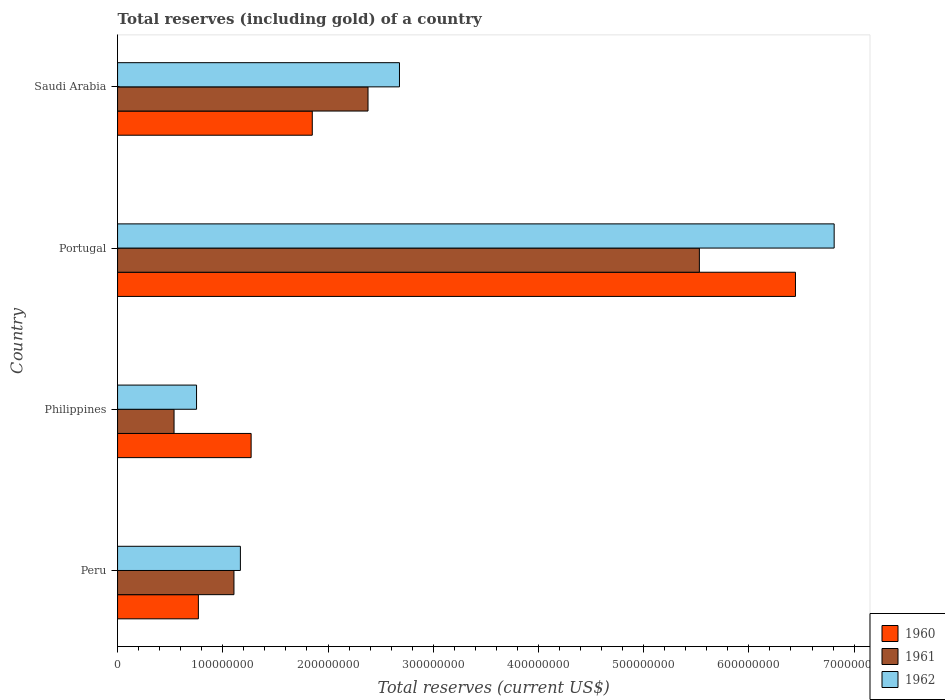How many groups of bars are there?
Offer a very short reply. 4. Are the number of bars per tick equal to the number of legend labels?
Provide a short and direct response. Yes. How many bars are there on the 3rd tick from the top?
Your answer should be very brief. 3. How many bars are there on the 4th tick from the bottom?
Make the answer very short. 3. What is the label of the 4th group of bars from the top?
Provide a succinct answer. Peru. In how many cases, is the number of bars for a given country not equal to the number of legend labels?
Provide a short and direct response. 0. What is the total reserves (including gold) in 1961 in Saudi Arabia?
Make the answer very short. 2.38e+08. Across all countries, what is the maximum total reserves (including gold) in 1961?
Give a very brief answer. 5.53e+08. Across all countries, what is the minimum total reserves (including gold) in 1961?
Ensure brevity in your answer.  5.37e+07. In which country was the total reserves (including gold) in 1961 minimum?
Provide a short and direct response. Philippines. What is the total total reserves (including gold) in 1960 in the graph?
Your answer should be very brief. 1.03e+09. What is the difference between the total reserves (including gold) in 1961 in Peru and that in Portugal?
Provide a short and direct response. -4.42e+08. What is the difference between the total reserves (including gold) in 1961 in Peru and the total reserves (including gold) in 1962 in Saudi Arabia?
Your response must be concise. -1.57e+08. What is the average total reserves (including gold) in 1962 per country?
Ensure brevity in your answer.  2.85e+08. What is the difference between the total reserves (including gold) in 1961 and total reserves (including gold) in 1962 in Saudi Arabia?
Offer a terse response. -2.99e+07. What is the ratio of the total reserves (including gold) in 1961 in Peru to that in Philippines?
Offer a terse response. 2.06. Is the total reserves (including gold) in 1962 in Peru less than that in Portugal?
Your answer should be compact. Yes. Is the difference between the total reserves (including gold) in 1961 in Portugal and Saudi Arabia greater than the difference between the total reserves (including gold) in 1962 in Portugal and Saudi Arabia?
Keep it short and to the point. No. What is the difference between the highest and the second highest total reserves (including gold) in 1962?
Ensure brevity in your answer.  4.13e+08. What is the difference between the highest and the lowest total reserves (including gold) in 1962?
Offer a terse response. 6.06e+08. Is the sum of the total reserves (including gold) in 1960 in Philippines and Saudi Arabia greater than the maximum total reserves (including gold) in 1962 across all countries?
Your response must be concise. No. What does the 1st bar from the bottom in Philippines represents?
Your answer should be very brief. 1960. Is it the case that in every country, the sum of the total reserves (including gold) in 1962 and total reserves (including gold) in 1961 is greater than the total reserves (including gold) in 1960?
Keep it short and to the point. Yes. Are all the bars in the graph horizontal?
Your response must be concise. Yes. How many countries are there in the graph?
Your answer should be very brief. 4. Are the values on the major ticks of X-axis written in scientific E-notation?
Offer a very short reply. No. Does the graph contain any zero values?
Provide a short and direct response. No. Does the graph contain grids?
Provide a short and direct response. No. Where does the legend appear in the graph?
Your answer should be very brief. Bottom right. How are the legend labels stacked?
Ensure brevity in your answer.  Vertical. What is the title of the graph?
Keep it short and to the point. Total reserves (including gold) of a country. Does "1974" appear as one of the legend labels in the graph?
Give a very brief answer. No. What is the label or title of the X-axis?
Your response must be concise. Total reserves (current US$). What is the label or title of the Y-axis?
Provide a short and direct response. Country. What is the Total reserves (current US$) in 1960 in Peru?
Your answer should be very brief. 7.68e+07. What is the Total reserves (current US$) in 1961 in Peru?
Give a very brief answer. 1.11e+08. What is the Total reserves (current US$) in 1962 in Peru?
Your response must be concise. 1.17e+08. What is the Total reserves (current US$) of 1960 in Philippines?
Ensure brevity in your answer.  1.27e+08. What is the Total reserves (current US$) in 1961 in Philippines?
Provide a short and direct response. 5.37e+07. What is the Total reserves (current US$) of 1962 in Philippines?
Provide a short and direct response. 7.51e+07. What is the Total reserves (current US$) of 1960 in Portugal?
Offer a terse response. 6.44e+08. What is the Total reserves (current US$) of 1961 in Portugal?
Make the answer very short. 5.53e+08. What is the Total reserves (current US$) in 1962 in Portugal?
Ensure brevity in your answer.  6.81e+08. What is the Total reserves (current US$) of 1960 in Saudi Arabia?
Provide a short and direct response. 1.85e+08. What is the Total reserves (current US$) in 1961 in Saudi Arabia?
Your answer should be compact. 2.38e+08. What is the Total reserves (current US$) of 1962 in Saudi Arabia?
Your response must be concise. 2.68e+08. Across all countries, what is the maximum Total reserves (current US$) of 1960?
Your response must be concise. 6.44e+08. Across all countries, what is the maximum Total reserves (current US$) in 1961?
Your answer should be very brief. 5.53e+08. Across all countries, what is the maximum Total reserves (current US$) of 1962?
Ensure brevity in your answer.  6.81e+08. Across all countries, what is the minimum Total reserves (current US$) in 1960?
Offer a terse response. 7.68e+07. Across all countries, what is the minimum Total reserves (current US$) in 1961?
Offer a very short reply. 5.37e+07. Across all countries, what is the minimum Total reserves (current US$) in 1962?
Provide a short and direct response. 7.51e+07. What is the total Total reserves (current US$) of 1960 in the graph?
Provide a succinct answer. 1.03e+09. What is the total Total reserves (current US$) of 1961 in the graph?
Give a very brief answer. 9.55e+08. What is the total Total reserves (current US$) in 1962 in the graph?
Make the answer very short. 1.14e+09. What is the difference between the Total reserves (current US$) of 1960 in Peru and that in Philippines?
Give a very brief answer. -5.01e+07. What is the difference between the Total reserves (current US$) of 1961 in Peru and that in Philippines?
Provide a short and direct response. 5.69e+07. What is the difference between the Total reserves (current US$) of 1962 in Peru and that in Philippines?
Keep it short and to the point. 4.17e+07. What is the difference between the Total reserves (current US$) in 1960 in Peru and that in Portugal?
Your answer should be compact. -5.67e+08. What is the difference between the Total reserves (current US$) of 1961 in Peru and that in Portugal?
Your answer should be very brief. -4.42e+08. What is the difference between the Total reserves (current US$) in 1962 in Peru and that in Portugal?
Keep it short and to the point. -5.64e+08. What is the difference between the Total reserves (current US$) of 1960 in Peru and that in Saudi Arabia?
Offer a very short reply. -1.08e+08. What is the difference between the Total reserves (current US$) in 1961 in Peru and that in Saudi Arabia?
Your answer should be compact. -1.27e+08. What is the difference between the Total reserves (current US$) in 1962 in Peru and that in Saudi Arabia?
Give a very brief answer. -1.51e+08. What is the difference between the Total reserves (current US$) in 1960 in Philippines and that in Portugal?
Give a very brief answer. -5.17e+08. What is the difference between the Total reserves (current US$) of 1961 in Philippines and that in Portugal?
Ensure brevity in your answer.  -4.99e+08. What is the difference between the Total reserves (current US$) in 1962 in Philippines and that in Portugal?
Your answer should be compact. -6.06e+08. What is the difference between the Total reserves (current US$) of 1960 in Philippines and that in Saudi Arabia?
Provide a succinct answer. -5.81e+07. What is the difference between the Total reserves (current US$) of 1961 in Philippines and that in Saudi Arabia?
Ensure brevity in your answer.  -1.84e+08. What is the difference between the Total reserves (current US$) in 1962 in Philippines and that in Saudi Arabia?
Your response must be concise. -1.93e+08. What is the difference between the Total reserves (current US$) in 1960 in Portugal and that in Saudi Arabia?
Give a very brief answer. 4.59e+08. What is the difference between the Total reserves (current US$) of 1961 in Portugal and that in Saudi Arabia?
Offer a terse response. 3.15e+08. What is the difference between the Total reserves (current US$) of 1962 in Portugal and that in Saudi Arabia?
Provide a short and direct response. 4.13e+08. What is the difference between the Total reserves (current US$) in 1960 in Peru and the Total reserves (current US$) in 1961 in Philippines?
Make the answer very short. 2.31e+07. What is the difference between the Total reserves (current US$) in 1960 in Peru and the Total reserves (current US$) in 1962 in Philippines?
Offer a very short reply. 1.74e+06. What is the difference between the Total reserves (current US$) in 1961 in Peru and the Total reserves (current US$) in 1962 in Philippines?
Your answer should be compact. 3.56e+07. What is the difference between the Total reserves (current US$) in 1960 in Peru and the Total reserves (current US$) in 1961 in Portugal?
Keep it short and to the point. -4.76e+08. What is the difference between the Total reserves (current US$) of 1960 in Peru and the Total reserves (current US$) of 1962 in Portugal?
Your answer should be very brief. -6.04e+08. What is the difference between the Total reserves (current US$) of 1961 in Peru and the Total reserves (current US$) of 1962 in Portugal?
Make the answer very short. -5.70e+08. What is the difference between the Total reserves (current US$) of 1960 in Peru and the Total reserves (current US$) of 1961 in Saudi Arabia?
Keep it short and to the point. -1.61e+08. What is the difference between the Total reserves (current US$) of 1960 in Peru and the Total reserves (current US$) of 1962 in Saudi Arabia?
Ensure brevity in your answer.  -1.91e+08. What is the difference between the Total reserves (current US$) in 1961 in Peru and the Total reserves (current US$) in 1962 in Saudi Arabia?
Offer a very short reply. -1.57e+08. What is the difference between the Total reserves (current US$) in 1960 in Philippines and the Total reserves (current US$) in 1961 in Portugal?
Your response must be concise. -4.26e+08. What is the difference between the Total reserves (current US$) of 1960 in Philippines and the Total reserves (current US$) of 1962 in Portugal?
Provide a succinct answer. -5.54e+08. What is the difference between the Total reserves (current US$) of 1961 in Philippines and the Total reserves (current US$) of 1962 in Portugal?
Give a very brief answer. -6.27e+08. What is the difference between the Total reserves (current US$) in 1960 in Philippines and the Total reserves (current US$) in 1961 in Saudi Arabia?
Offer a terse response. -1.11e+08. What is the difference between the Total reserves (current US$) of 1960 in Philippines and the Total reserves (current US$) of 1962 in Saudi Arabia?
Keep it short and to the point. -1.41e+08. What is the difference between the Total reserves (current US$) in 1961 in Philippines and the Total reserves (current US$) in 1962 in Saudi Arabia?
Your response must be concise. -2.14e+08. What is the difference between the Total reserves (current US$) of 1960 in Portugal and the Total reserves (current US$) of 1961 in Saudi Arabia?
Your answer should be very brief. 4.06e+08. What is the difference between the Total reserves (current US$) in 1960 in Portugal and the Total reserves (current US$) in 1962 in Saudi Arabia?
Give a very brief answer. 3.76e+08. What is the difference between the Total reserves (current US$) of 1961 in Portugal and the Total reserves (current US$) of 1962 in Saudi Arabia?
Ensure brevity in your answer.  2.85e+08. What is the average Total reserves (current US$) in 1960 per country?
Offer a very short reply. 2.58e+08. What is the average Total reserves (current US$) of 1961 per country?
Give a very brief answer. 2.39e+08. What is the average Total reserves (current US$) of 1962 per country?
Offer a terse response. 2.85e+08. What is the difference between the Total reserves (current US$) of 1960 and Total reserves (current US$) of 1961 in Peru?
Give a very brief answer. -3.38e+07. What is the difference between the Total reserves (current US$) in 1960 and Total reserves (current US$) in 1962 in Peru?
Provide a short and direct response. -3.99e+07. What is the difference between the Total reserves (current US$) of 1961 and Total reserves (current US$) of 1962 in Peru?
Your response must be concise. -6.11e+06. What is the difference between the Total reserves (current US$) of 1960 and Total reserves (current US$) of 1961 in Philippines?
Make the answer very short. 7.33e+07. What is the difference between the Total reserves (current US$) in 1960 and Total reserves (current US$) in 1962 in Philippines?
Your response must be concise. 5.19e+07. What is the difference between the Total reserves (current US$) in 1961 and Total reserves (current US$) in 1962 in Philippines?
Keep it short and to the point. -2.14e+07. What is the difference between the Total reserves (current US$) in 1960 and Total reserves (current US$) in 1961 in Portugal?
Offer a very short reply. 9.13e+07. What is the difference between the Total reserves (current US$) in 1960 and Total reserves (current US$) in 1962 in Portugal?
Give a very brief answer. -3.68e+07. What is the difference between the Total reserves (current US$) of 1961 and Total reserves (current US$) of 1962 in Portugal?
Give a very brief answer. -1.28e+08. What is the difference between the Total reserves (current US$) of 1960 and Total reserves (current US$) of 1961 in Saudi Arabia?
Give a very brief answer. -5.30e+07. What is the difference between the Total reserves (current US$) of 1960 and Total reserves (current US$) of 1962 in Saudi Arabia?
Your response must be concise. -8.29e+07. What is the difference between the Total reserves (current US$) in 1961 and Total reserves (current US$) in 1962 in Saudi Arabia?
Give a very brief answer. -2.99e+07. What is the ratio of the Total reserves (current US$) in 1960 in Peru to that in Philippines?
Provide a short and direct response. 0.61. What is the ratio of the Total reserves (current US$) in 1961 in Peru to that in Philippines?
Give a very brief answer. 2.06. What is the ratio of the Total reserves (current US$) of 1962 in Peru to that in Philippines?
Give a very brief answer. 1.56. What is the ratio of the Total reserves (current US$) of 1960 in Peru to that in Portugal?
Provide a short and direct response. 0.12. What is the ratio of the Total reserves (current US$) in 1961 in Peru to that in Portugal?
Offer a terse response. 0.2. What is the ratio of the Total reserves (current US$) in 1962 in Peru to that in Portugal?
Provide a succinct answer. 0.17. What is the ratio of the Total reserves (current US$) in 1960 in Peru to that in Saudi Arabia?
Your response must be concise. 0.42. What is the ratio of the Total reserves (current US$) of 1961 in Peru to that in Saudi Arabia?
Keep it short and to the point. 0.46. What is the ratio of the Total reserves (current US$) in 1962 in Peru to that in Saudi Arabia?
Make the answer very short. 0.44. What is the ratio of the Total reserves (current US$) in 1960 in Philippines to that in Portugal?
Keep it short and to the point. 0.2. What is the ratio of the Total reserves (current US$) of 1961 in Philippines to that in Portugal?
Provide a succinct answer. 0.1. What is the ratio of the Total reserves (current US$) in 1962 in Philippines to that in Portugal?
Your answer should be very brief. 0.11. What is the ratio of the Total reserves (current US$) of 1960 in Philippines to that in Saudi Arabia?
Offer a terse response. 0.69. What is the ratio of the Total reserves (current US$) of 1961 in Philippines to that in Saudi Arabia?
Offer a very short reply. 0.23. What is the ratio of the Total reserves (current US$) in 1962 in Philippines to that in Saudi Arabia?
Offer a terse response. 0.28. What is the ratio of the Total reserves (current US$) in 1960 in Portugal to that in Saudi Arabia?
Offer a terse response. 3.48. What is the ratio of the Total reserves (current US$) of 1961 in Portugal to that in Saudi Arabia?
Offer a very short reply. 2.32. What is the ratio of the Total reserves (current US$) in 1962 in Portugal to that in Saudi Arabia?
Make the answer very short. 2.54. What is the difference between the highest and the second highest Total reserves (current US$) of 1960?
Keep it short and to the point. 4.59e+08. What is the difference between the highest and the second highest Total reserves (current US$) of 1961?
Your response must be concise. 3.15e+08. What is the difference between the highest and the second highest Total reserves (current US$) in 1962?
Provide a succinct answer. 4.13e+08. What is the difference between the highest and the lowest Total reserves (current US$) of 1960?
Provide a succinct answer. 5.67e+08. What is the difference between the highest and the lowest Total reserves (current US$) in 1961?
Offer a very short reply. 4.99e+08. What is the difference between the highest and the lowest Total reserves (current US$) of 1962?
Make the answer very short. 6.06e+08. 